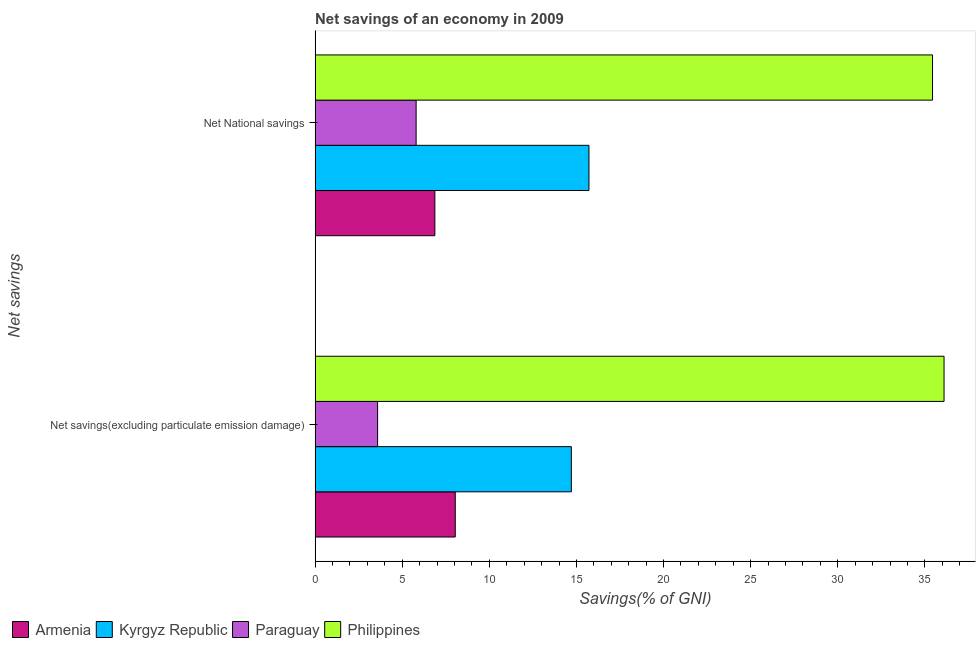How many groups of bars are there?
Give a very brief answer. 2. How many bars are there on the 1st tick from the bottom?
Your answer should be very brief. 4. What is the label of the 2nd group of bars from the top?
Offer a very short reply. Net savings(excluding particulate emission damage). What is the net savings(excluding particulate emission damage) in Paraguay?
Provide a short and direct response. 3.59. Across all countries, what is the maximum net national savings?
Offer a terse response. 35.44. Across all countries, what is the minimum net savings(excluding particulate emission damage)?
Make the answer very short. 3.59. In which country was the net savings(excluding particulate emission damage) minimum?
Your answer should be very brief. Paraguay. What is the total net savings(excluding particulate emission damage) in the graph?
Your response must be concise. 62.44. What is the difference between the net savings(excluding particulate emission damage) in Philippines and that in Armenia?
Offer a terse response. 28.06. What is the difference between the net savings(excluding particulate emission damage) in Paraguay and the net national savings in Philippines?
Keep it short and to the point. -31.85. What is the average net savings(excluding particulate emission damage) per country?
Give a very brief answer. 15.61. What is the difference between the net national savings and net savings(excluding particulate emission damage) in Philippines?
Ensure brevity in your answer.  -0.66. In how many countries, is the net savings(excluding particulate emission damage) greater than 16 %?
Keep it short and to the point. 1. What is the ratio of the net national savings in Kyrgyz Republic to that in Armenia?
Provide a succinct answer. 2.29. In how many countries, is the net savings(excluding particulate emission damage) greater than the average net savings(excluding particulate emission damage) taken over all countries?
Offer a terse response. 1. What does the 2nd bar from the bottom in Net National savings represents?
Provide a short and direct response. Kyrgyz Republic. How many bars are there?
Your answer should be very brief. 8. Are all the bars in the graph horizontal?
Offer a very short reply. Yes. Does the graph contain grids?
Your response must be concise. No. How are the legend labels stacked?
Provide a short and direct response. Horizontal. What is the title of the graph?
Give a very brief answer. Net savings of an economy in 2009. What is the label or title of the X-axis?
Make the answer very short. Savings(% of GNI). What is the label or title of the Y-axis?
Provide a short and direct response. Net savings. What is the Savings(% of GNI) in Armenia in Net savings(excluding particulate emission damage)?
Provide a short and direct response. 8.04. What is the Savings(% of GNI) in Kyrgyz Republic in Net savings(excluding particulate emission damage)?
Ensure brevity in your answer.  14.71. What is the Savings(% of GNI) in Paraguay in Net savings(excluding particulate emission damage)?
Ensure brevity in your answer.  3.59. What is the Savings(% of GNI) in Philippines in Net savings(excluding particulate emission damage)?
Keep it short and to the point. 36.1. What is the Savings(% of GNI) in Armenia in Net National savings?
Give a very brief answer. 6.87. What is the Savings(% of GNI) in Kyrgyz Republic in Net National savings?
Your answer should be very brief. 15.72. What is the Savings(% of GNI) in Paraguay in Net National savings?
Your answer should be compact. 5.8. What is the Savings(% of GNI) in Philippines in Net National savings?
Your answer should be compact. 35.44. Across all Net savings, what is the maximum Savings(% of GNI) in Armenia?
Your answer should be very brief. 8.04. Across all Net savings, what is the maximum Savings(% of GNI) of Kyrgyz Republic?
Provide a short and direct response. 15.72. Across all Net savings, what is the maximum Savings(% of GNI) in Paraguay?
Your answer should be compact. 5.8. Across all Net savings, what is the maximum Savings(% of GNI) in Philippines?
Provide a short and direct response. 36.1. Across all Net savings, what is the minimum Savings(% of GNI) in Armenia?
Keep it short and to the point. 6.87. Across all Net savings, what is the minimum Savings(% of GNI) in Kyrgyz Republic?
Give a very brief answer. 14.71. Across all Net savings, what is the minimum Savings(% of GNI) of Paraguay?
Give a very brief answer. 3.59. Across all Net savings, what is the minimum Savings(% of GNI) of Philippines?
Keep it short and to the point. 35.44. What is the total Savings(% of GNI) in Armenia in the graph?
Your response must be concise. 14.92. What is the total Savings(% of GNI) of Kyrgyz Republic in the graph?
Provide a short and direct response. 30.43. What is the total Savings(% of GNI) in Paraguay in the graph?
Give a very brief answer. 9.39. What is the total Savings(% of GNI) of Philippines in the graph?
Provide a short and direct response. 71.54. What is the difference between the Savings(% of GNI) in Armenia in Net savings(excluding particulate emission damage) and that in Net National savings?
Your answer should be compact. 1.17. What is the difference between the Savings(% of GNI) of Kyrgyz Republic in Net savings(excluding particulate emission damage) and that in Net National savings?
Your answer should be very brief. -1.01. What is the difference between the Savings(% of GNI) in Paraguay in Net savings(excluding particulate emission damage) and that in Net National savings?
Your answer should be compact. -2.21. What is the difference between the Savings(% of GNI) in Philippines in Net savings(excluding particulate emission damage) and that in Net National savings?
Keep it short and to the point. 0.66. What is the difference between the Savings(% of GNI) of Armenia in Net savings(excluding particulate emission damage) and the Savings(% of GNI) of Kyrgyz Republic in Net National savings?
Offer a very short reply. -7.67. What is the difference between the Savings(% of GNI) of Armenia in Net savings(excluding particulate emission damage) and the Savings(% of GNI) of Paraguay in Net National savings?
Provide a succinct answer. 2.25. What is the difference between the Savings(% of GNI) of Armenia in Net savings(excluding particulate emission damage) and the Savings(% of GNI) of Philippines in Net National savings?
Make the answer very short. -27.39. What is the difference between the Savings(% of GNI) of Kyrgyz Republic in Net savings(excluding particulate emission damage) and the Savings(% of GNI) of Paraguay in Net National savings?
Provide a succinct answer. 8.91. What is the difference between the Savings(% of GNI) in Kyrgyz Republic in Net savings(excluding particulate emission damage) and the Savings(% of GNI) in Philippines in Net National savings?
Keep it short and to the point. -20.73. What is the difference between the Savings(% of GNI) in Paraguay in Net savings(excluding particulate emission damage) and the Savings(% of GNI) in Philippines in Net National savings?
Offer a terse response. -31.85. What is the average Savings(% of GNI) of Armenia per Net savings?
Keep it short and to the point. 7.46. What is the average Savings(% of GNI) in Kyrgyz Republic per Net savings?
Offer a terse response. 15.21. What is the average Savings(% of GNI) in Paraguay per Net savings?
Keep it short and to the point. 4.69. What is the average Savings(% of GNI) in Philippines per Net savings?
Offer a terse response. 35.77. What is the difference between the Savings(% of GNI) of Armenia and Savings(% of GNI) of Kyrgyz Republic in Net savings(excluding particulate emission damage)?
Your answer should be very brief. -6.66. What is the difference between the Savings(% of GNI) in Armenia and Savings(% of GNI) in Paraguay in Net savings(excluding particulate emission damage)?
Offer a very short reply. 4.46. What is the difference between the Savings(% of GNI) of Armenia and Savings(% of GNI) of Philippines in Net savings(excluding particulate emission damage)?
Your answer should be very brief. -28.06. What is the difference between the Savings(% of GNI) in Kyrgyz Republic and Savings(% of GNI) in Paraguay in Net savings(excluding particulate emission damage)?
Make the answer very short. 11.12. What is the difference between the Savings(% of GNI) of Kyrgyz Republic and Savings(% of GNI) of Philippines in Net savings(excluding particulate emission damage)?
Offer a terse response. -21.39. What is the difference between the Savings(% of GNI) of Paraguay and Savings(% of GNI) of Philippines in Net savings(excluding particulate emission damage)?
Give a very brief answer. -32.51. What is the difference between the Savings(% of GNI) of Armenia and Savings(% of GNI) of Kyrgyz Republic in Net National savings?
Ensure brevity in your answer.  -8.85. What is the difference between the Savings(% of GNI) of Armenia and Savings(% of GNI) of Paraguay in Net National savings?
Give a very brief answer. 1.08. What is the difference between the Savings(% of GNI) of Armenia and Savings(% of GNI) of Philippines in Net National savings?
Keep it short and to the point. -28.57. What is the difference between the Savings(% of GNI) in Kyrgyz Republic and Savings(% of GNI) in Paraguay in Net National savings?
Your answer should be compact. 9.92. What is the difference between the Savings(% of GNI) in Kyrgyz Republic and Savings(% of GNI) in Philippines in Net National savings?
Provide a short and direct response. -19.72. What is the difference between the Savings(% of GNI) of Paraguay and Savings(% of GNI) of Philippines in Net National savings?
Give a very brief answer. -29.64. What is the ratio of the Savings(% of GNI) in Armenia in Net savings(excluding particulate emission damage) to that in Net National savings?
Your answer should be very brief. 1.17. What is the ratio of the Savings(% of GNI) of Kyrgyz Republic in Net savings(excluding particulate emission damage) to that in Net National savings?
Your response must be concise. 0.94. What is the ratio of the Savings(% of GNI) of Paraguay in Net savings(excluding particulate emission damage) to that in Net National savings?
Give a very brief answer. 0.62. What is the ratio of the Savings(% of GNI) in Philippines in Net savings(excluding particulate emission damage) to that in Net National savings?
Your answer should be compact. 1.02. What is the difference between the highest and the second highest Savings(% of GNI) of Armenia?
Your answer should be very brief. 1.17. What is the difference between the highest and the second highest Savings(% of GNI) of Kyrgyz Republic?
Make the answer very short. 1.01. What is the difference between the highest and the second highest Savings(% of GNI) in Paraguay?
Make the answer very short. 2.21. What is the difference between the highest and the second highest Savings(% of GNI) of Philippines?
Make the answer very short. 0.66. What is the difference between the highest and the lowest Savings(% of GNI) in Armenia?
Provide a short and direct response. 1.17. What is the difference between the highest and the lowest Savings(% of GNI) in Kyrgyz Republic?
Offer a terse response. 1.01. What is the difference between the highest and the lowest Savings(% of GNI) in Paraguay?
Make the answer very short. 2.21. What is the difference between the highest and the lowest Savings(% of GNI) of Philippines?
Give a very brief answer. 0.66. 